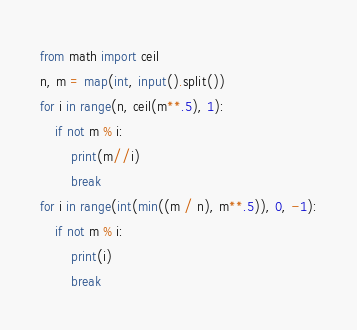Convert code to text. <code><loc_0><loc_0><loc_500><loc_500><_Python_>from math import ceil
n, m = map(int, input().split())
for i in range(n, ceil(m**.5), 1):
    if not m % i:
        print(m//i)
        break
for i in range(int(min((m / n), m**.5)), 0, -1):
    if not m % i:
        print(i)
        break
</code> 